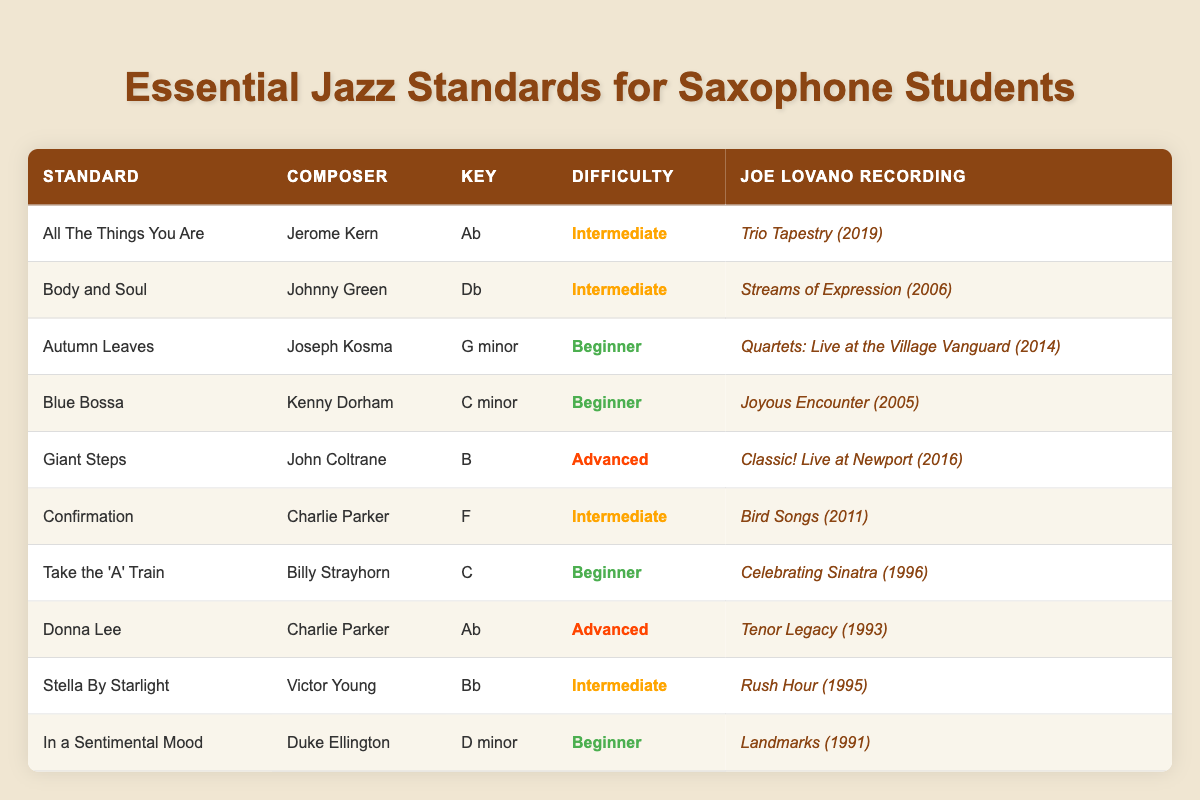What is the composer of "Body and Soul"? The table lists "Body and Soul" in the first row, and the composer is shown in the second column next to it.
Answer: Johnny Green Which standard is in the key of B? In the table, I can look down the "Key" column to find the row where the key is "B". The corresponding standard in that row is "Giant Steps".
Answer: Giant Steps How many advanced difficulty standards are listed? Counting the difficulty column, I see two rows marked as "Advanced": "Giant Steps" and "Donna Lee", which gives a total of two advanced standards.
Answer: 2 Is "Autumn Leaves" a beginner level standard? By checking the "Difficulty" column for the row with "Autumn Leaves", it is marked as "Beginner". Thus, the statement is true.
Answer: Yes What Joe Lovano recording is associated with the standard "Take the 'A' Train"? The table shows the fifth column for "Take the 'A' Train", where it lists the corresponding Joe Lovano recording.
Answer: Celebrating Sinatra (1996) Which standard has the same difficulty level as "Confirmation"? Looking at the table, "Confirmation" is marked as "Intermediate". The standards also classified as "Intermediate" are "All The Things You Are", "Body and Soul", "Stella By Starlight".
Answer: All The Things You Are, Body and Soul, Stella By Starlight What is the average difficulty level of the standards listed for beginners? To find the average, I need to count that there are four beginner standards: "Autumn Leaves," "Blue Bossa," "Take the 'A' Train," and "In a Sentimental Mood". Since there are no numerical values for difficulty, we can consider a scale where Beginner = 1, Intermediate = 2, Advanced = 3. Therefore, the sum for beginners is 1 * 4 = 4. The average difficulty level (4/4) is equal to 1.
Answer: 1 Which standard has the highest difficulty rating? By reviewing the "Difficulty" column, I can identify that "Giant Steps" and "Donna Lee" are marked as "Advanced". However, since they're both at the same level, we could say that both are the hardest standards.
Answer: Giant Steps and Donna Lee Is the standard "In a Sentimental Mood" composed by a famous jazz artist? Checking the table, "In a Sentimental Mood" is attributed to Duke Ellington, who is indeed a highly regarded figure in jazz history. Thus, the statement is true.
Answer: Yes 